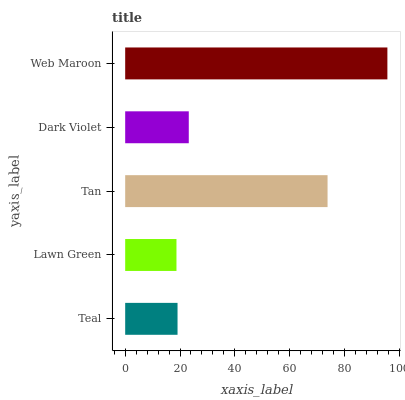Is Lawn Green the minimum?
Answer yes or no. Yes. Is Web Maroon the maximum?
Answer yes or no. Yes. Is Tan the minimum?
Answer yes or no. No. Is Tan the maximum?
Answer yes or no. No. Is Tan greater than Lawn Green?
Answer yes or no. Yes. Is Lawn Green less than Tan?
Answer yes or no. Yes. Is Lawn Green greater than Tan?
Answer yes or no. No. Is Tan less than Lawn Green?
Answer yes or no. No. Is Dark Violet the high median?
Answer yes or no. Yes. Is Dark Violet the low median?
Answer yes or no. Yes. Is Lawn Green the high median?
Answer yes or no. No. Is Tan the low median?
Answer yes or no. No. 